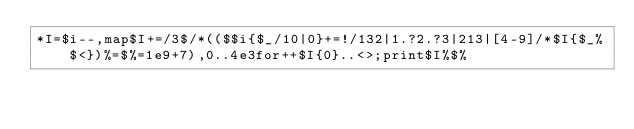Convert code to text. <code><loc_0><loc_0><loc_500><loc_500><_Perl_>*I=$i--,map$I+=/3$/*(($$i{$_/10|0}+=!/132|1.?2.?3|213|[4-9]/*$I{$_%$<})%=$%=1e9+7),0..4e3for++$I{0}..<>;print$I%$%</code> 